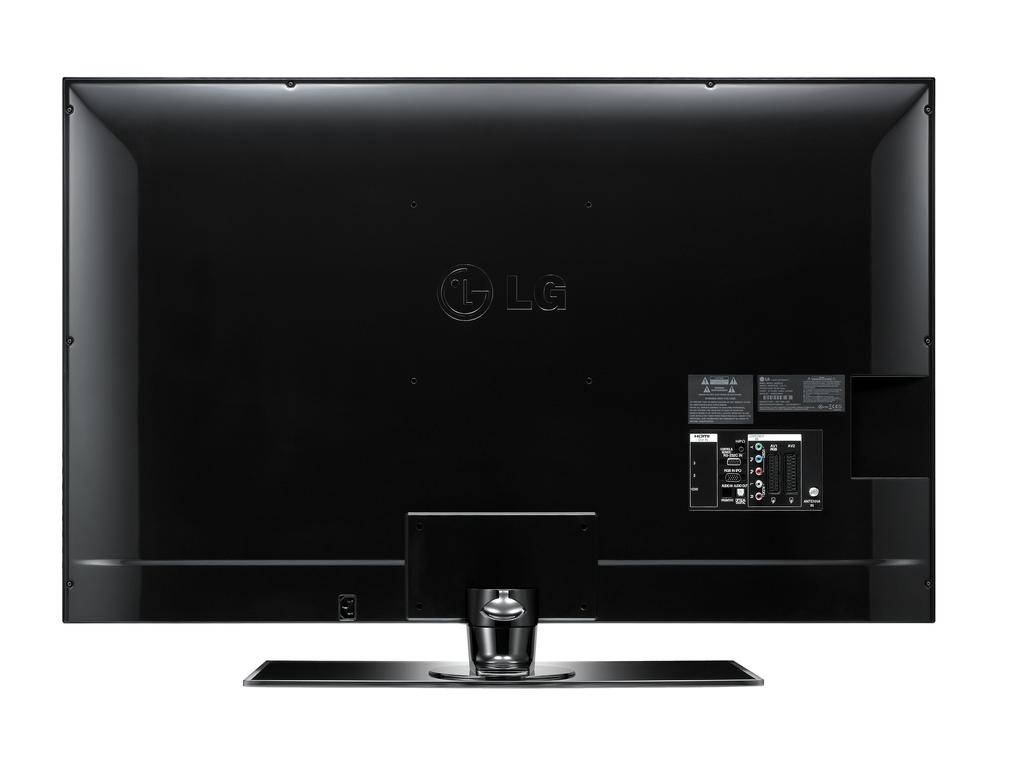What is the brand of this monitor?
Provide a short and direct response. Lg. 